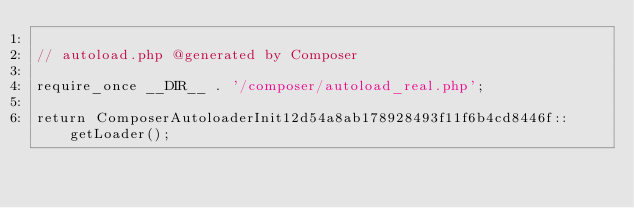<code> <loc_0><loc_0><loc_500><loc_500><_PHP_>
// autoload.php @generated by Composer

require_once __DIR__ . '/composer/autoload_real.php';

return ComposerAutoloaderInit12d54a8ab178928493f11f6b4cd8446f::getLoader();
</code> 